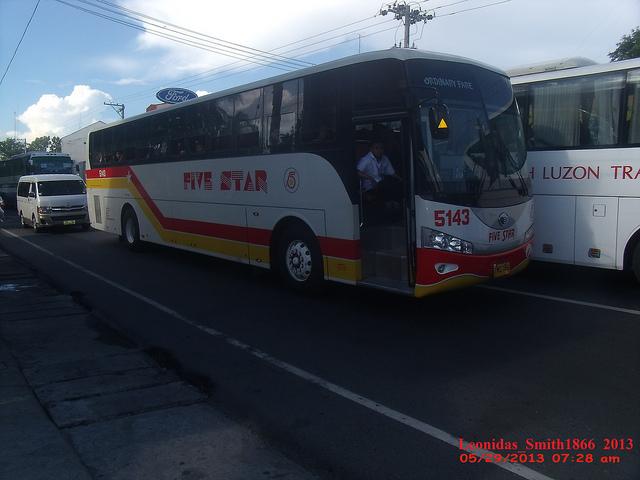What company is on the sign behind the bus?
Concise answer only. Ford. What number is on the front of the bus?
Write a very short answer. 5143. Why does each bus have a different name on the side?
Give a very brief answer. Different companies. What bus line is closest to the sidewalk?
Keep it brief. 5 star. What number is on front of the bus?
Keep it brief. 5143. What number is on the bus?
Short answer required. 5143. Are the bus doors open?
Short answer required. Yes. What are the words on the side of the bus?
Give a very brief answer. Five star. What are the 4 red numbers in the front of the bus?
Be succinct. 5143. 